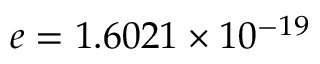Convert formula to latex. <formula><loc_0><loc_0><loc_500><loc_500>e = 1 . 6 0 2 1 \times 1 0 ^ { - 1 9 }</formula> 